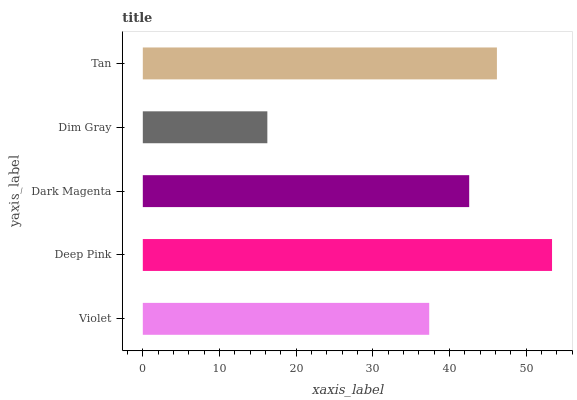Is Dim Gray the minimum?
Answer yes or no. Yes. Is Deep Pink the maximum?
Answer yes or no. Yes. Is Dark Magenta the minimum?
Answer yes or no. No. Is Dark Magenta the maximum?
Answer yes or no. No. Is Deep Pink greater than Dark Magenta?
Answer yes or no. Yes. Is Dark Magenta less than Deep Pink?
Answer yes or no. Yes. Is Dark Magenta greater than Deep Pink?
Answer yes or no. No. Is Deep Pink less than Dark Magenta?
Answer yes or no. No. Is Dark Magenta the high median?
Answer yes or no. Yes. Is Dark Magenta the low median?
Answer yes or no. Yes. Is Violet the high median?
Answer yes or no. No. Is Violet the low median?
Answer yes or no. No. 